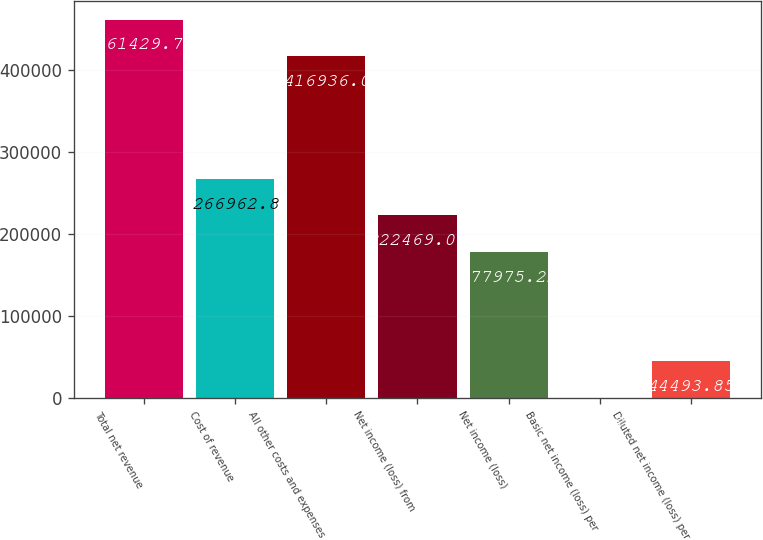Convert chart. <chart><loc_0><loc_0><loc_500><loc_500><bar_chart><fcel>Total net revenue<fcel>Cost of revenue<fcel>All other costs and expenses<fcel>Net income (loss) from<fcel>Net income (loss)<fcel>Basic net income (loss) per<fcel>Diluted net income (loss) per<nl><fcel>461430<fcel>266963<fcel>416936<fcel>222469<fcel>177975<fcel>0.06<fcel>44493.8<nl></chart> 